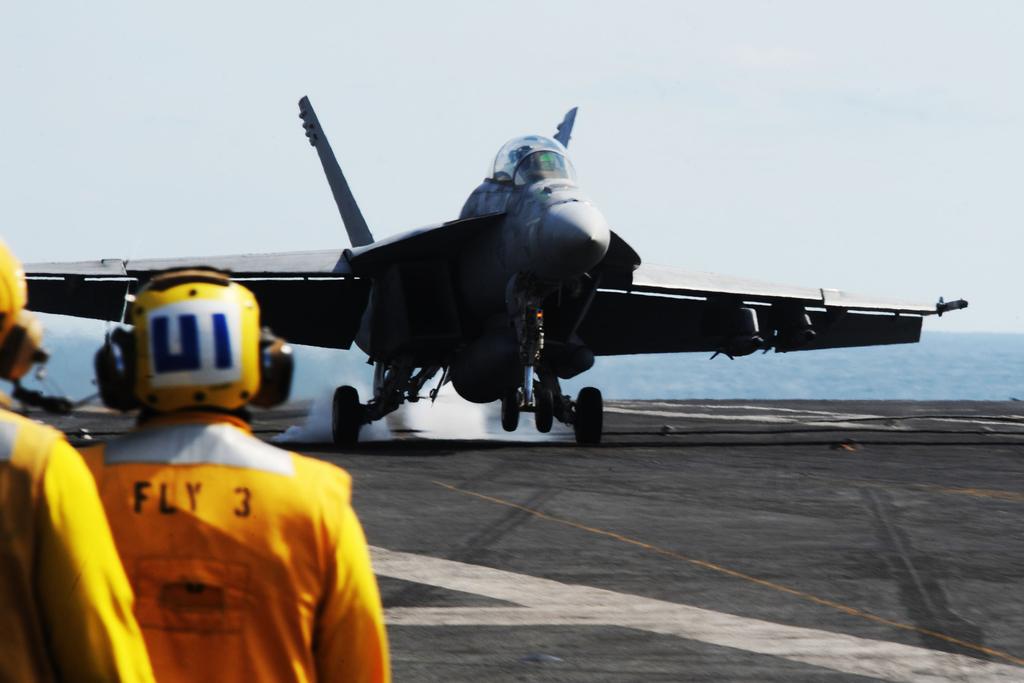What number is on the guys yellow jacket?
Give a very brief answer. 3. 